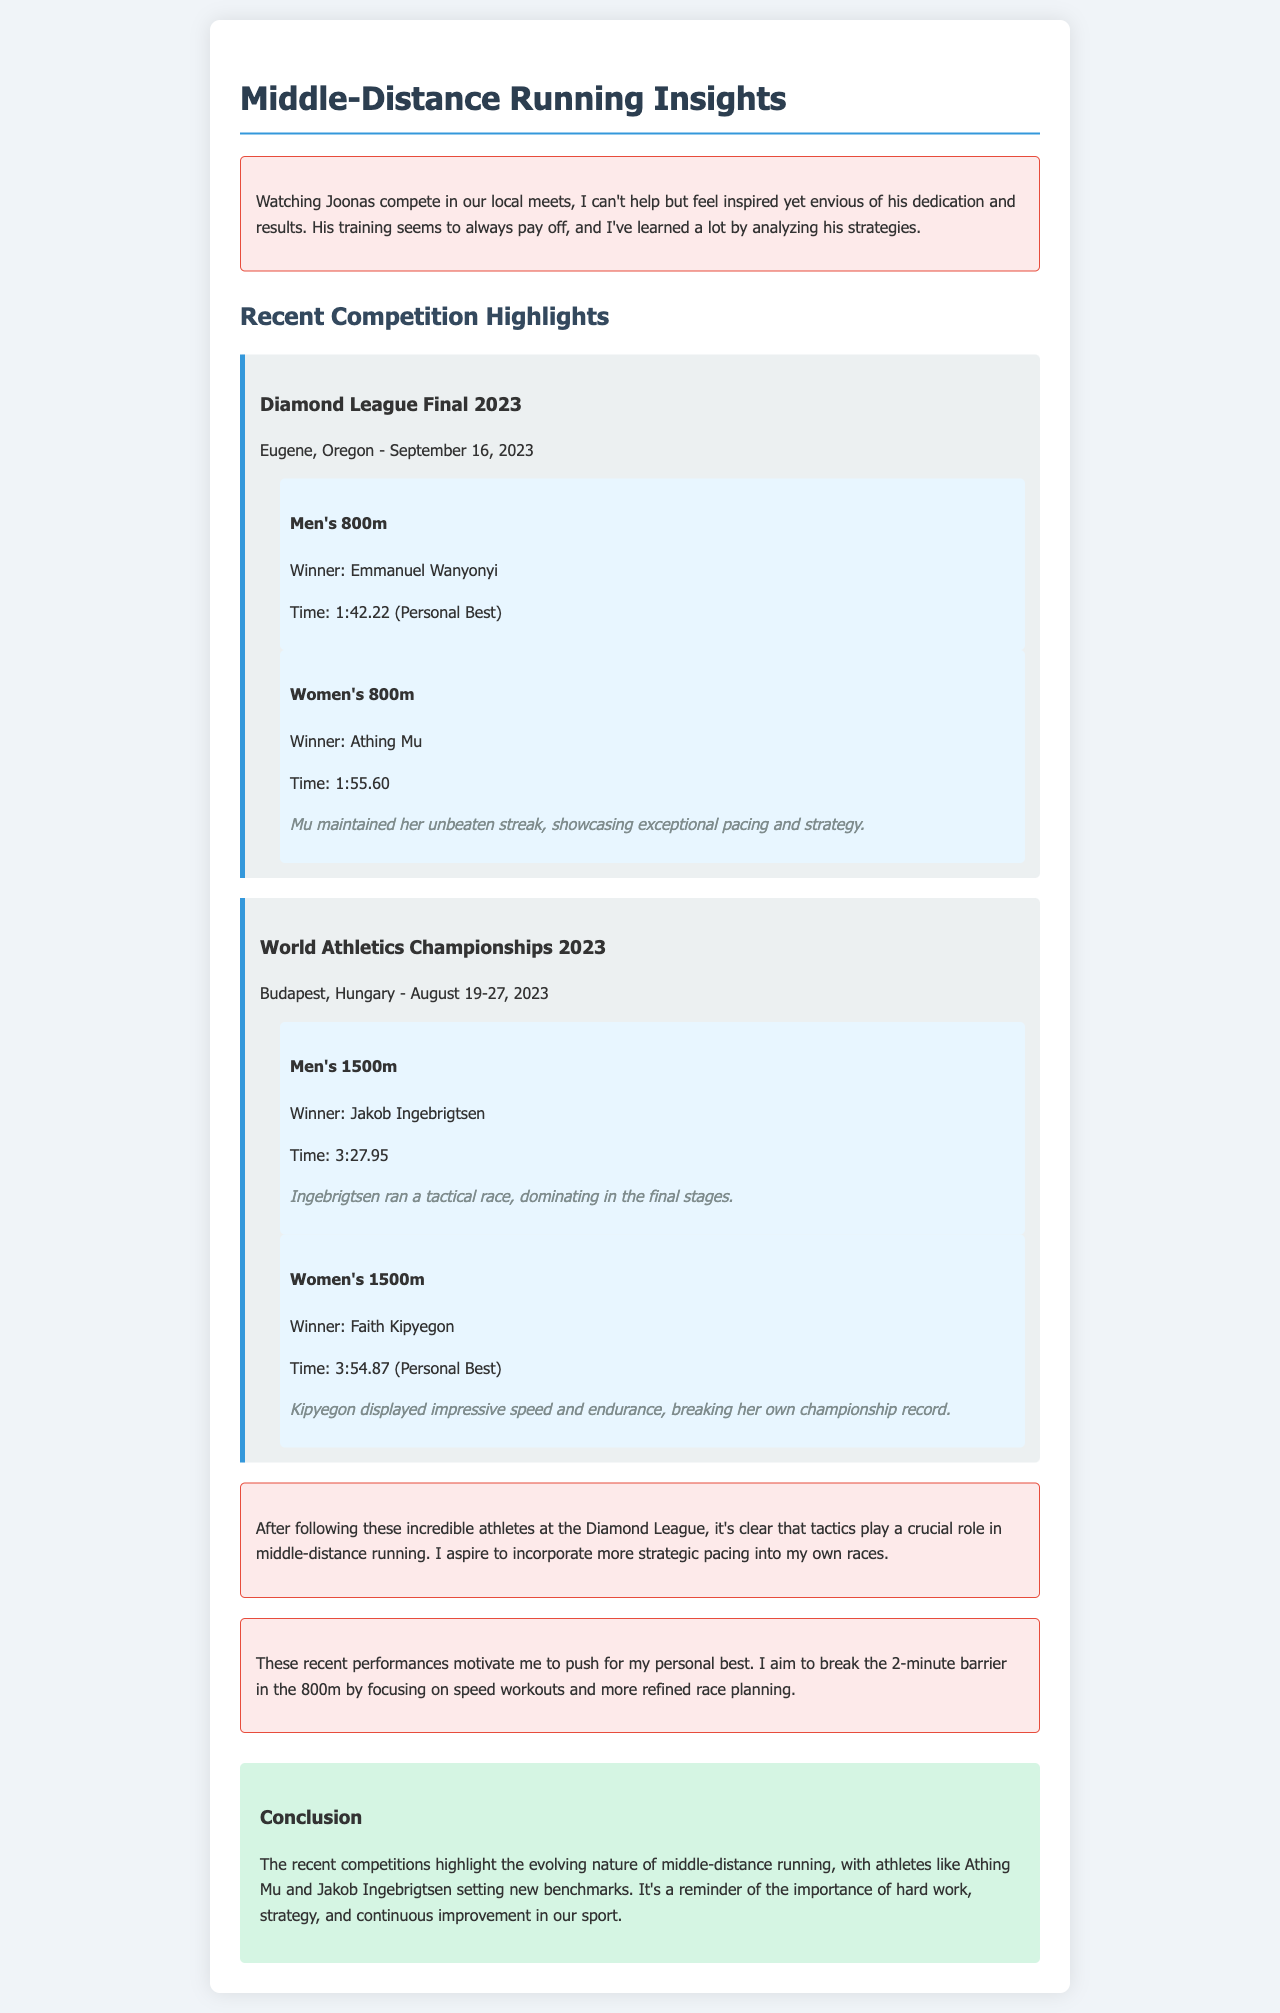What was the date of the Diamond League Final? The document states that the Diamond League Final took place on September 16, 2023.
Answer: September 16, 2023 Who won the Women's 800m at the Diamond League Final? The highlight section specifies that Athing Mu was the winner of the Women's 800m.
Answer: Athing Mu What time did Faith Kipyegon achieve in the Women's 1500m at the World Athletics Championships? The document provides Faith Kipyegon's winning time as 3:54.87.
Answer: 3:54.87 What was the personal best time recorded at the Diamond League Final? Emmanuel Wanyonyi achieved a personal best time of 1:42.22 in the Men's 800m.
Answer: 1:42.22 How did Jakob Ingebrigtsen win the Men's 1500m race? The document mentions that Jakob Ingebrigtsen ran a tactical race, dominating in the final stages.
Answer: Tactical race What aspect of middle-distance running does the author emphasize based on recent competitions? The author highlights that tactics play a crucial role in middle-distance running.
Answer: Tactics What personal goal does the author aspire to achieve in the 800m? The author mentions the aim to break the 2-minute barrier in the 800m.
Answer: Break the 2-minute barrier Which athlete's strategy does the author reflect on while watching the local meets? The author feels inspired by Joonas Rinne's dedication and results.
Answer: Joonas Rinne What conclusion is drawn about middle-distance running from recent competitions? The document concludes that hard work, strategy, and continuous improvement are important in the sport.
Answer: Hard work, strategy, and continuous improvement 